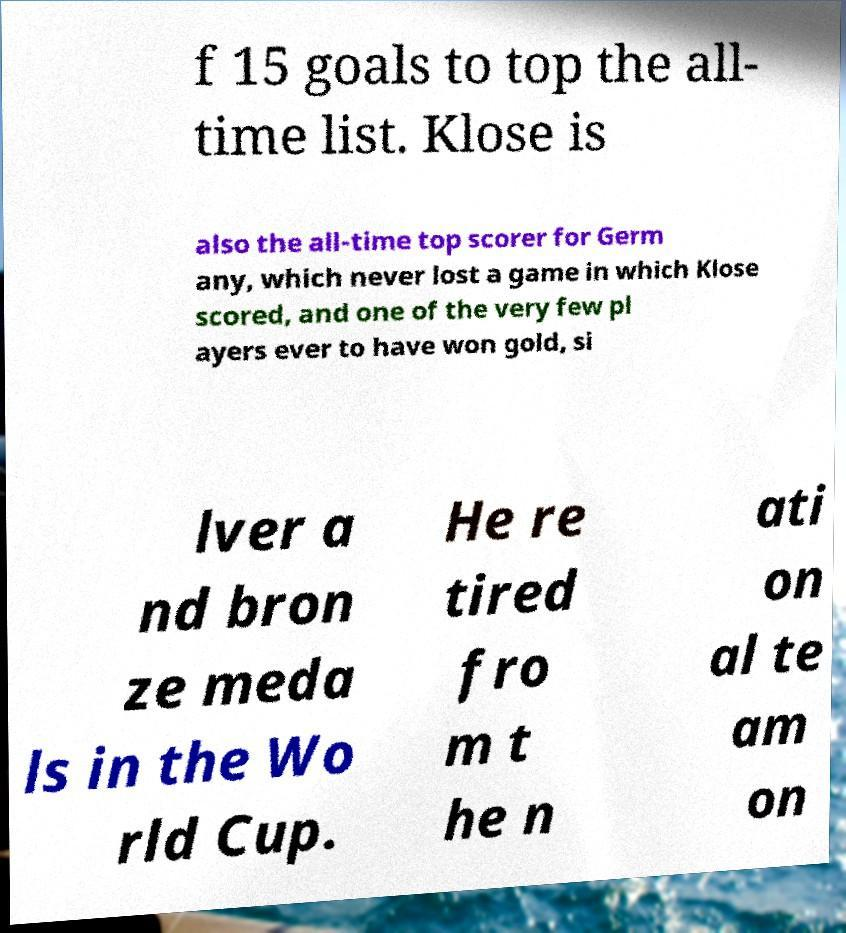Can you read and provide the text displayed in the image?This photo seems to have some interesting text. Can you extract and type it out for me? f 15 goals to top the all- time list. Klose is also the all-time top scorer for Germ any, which never lost a game in which Klose scored, and one of the very few pl ayers ever to have won gold, si lver a nd bron ze meda ls in the Wo rld Cup. He re tired fro m t he n ati on al te am on 